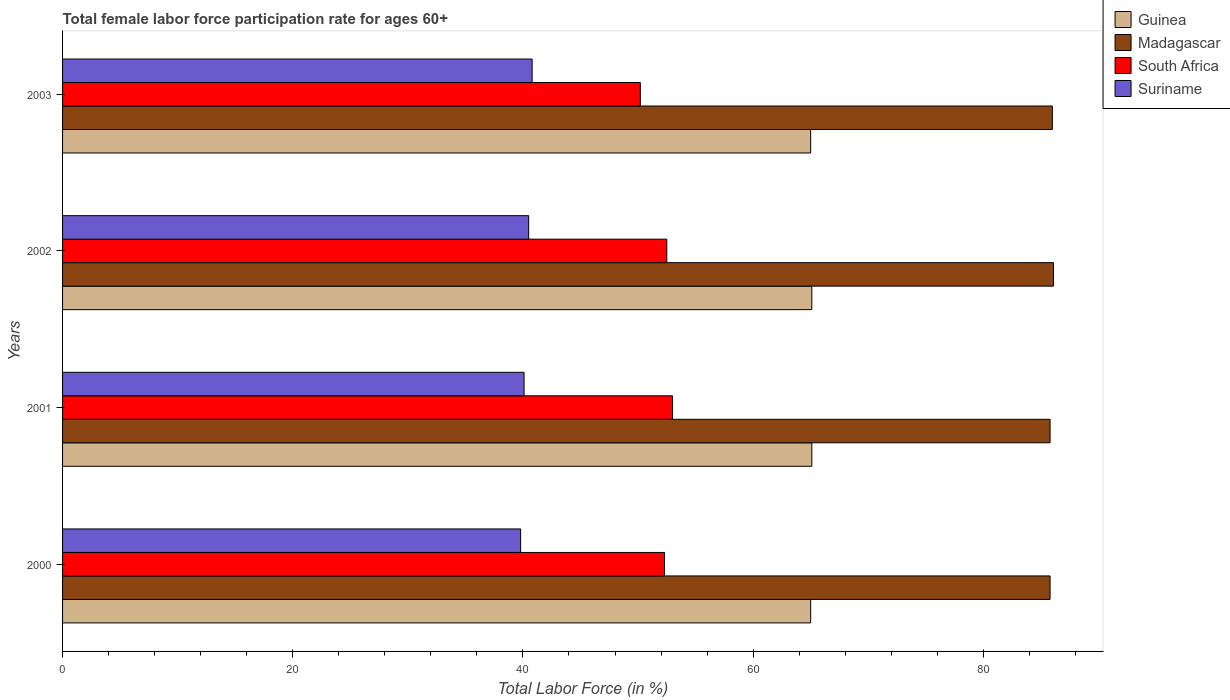How many different coloured bars are there?
Ensure brevity in your answer.  4. How many groups of bars are there?
Make the answer very short. 4. How many bars are there on the 4th tick from the bottom?
Ensure brevity in your answer.  4. In how many cases, is the number of bars for a given year not equal to the number of legend labels?
Your response must be concise. 0. What is the female labor force participation rate in South Africa in 2003?
Offer a terse response. 50.2. Across all years, what is the minimum female labor force participation rate in Suriname?
Make the answer very short. 39.8. In which year was the female labor force participation rate in Suriname maximum?
Make the answer very short. 2003. In which year was the female labor force participation rate in South Africa minimum?
Your answer should be compact. 2003. What is the total female labor force participation rate in South Africa in the graph?
Make the answer very short. 208. What is the difference between the female labor force participation rate in Suriname in 2000 and that in 2003?
Ensure brevity in your answer.  -1. In the year 2003, what is the difference between the female labor force participation rate in South Africa and female labor force participation rate in Suriname?
Your answer should be compact. 9.4. In how many years, is the female labor force participation rate in Madagascar greater than 40 %?
Your answer should be compact. 4. What is the ratio of the female labor force participation rate in Suriname in 2001 to that in 2003?
Ensure brevity in your answer.  0.98. Is the female labor force participation rate in Suriname in 2001 less than that in 2003?
Your answer should be very brief. Yes. What is the difference between the highest and the second highest female labor force participation rate in Madagascar?
Your answer should be very brief. 0.1. What is the difference between the highest and the lowest female labor force participation rate in Guinea?
Give a very brief answer. 0.1. In how many years, is the female labor force participation rate in Guinea greater than the average female labor force participation rate in Guinea taken over all years?
Your response must be concise. 2. Is the sum of the female labor force participation rate in Suriname in 2001 and 2003 greater than the maximum female labor force participation rate in Guinea across all years?
Give a very brief answer. Yes. What does the 4th bar from the top in 2002 represents?
Keep it short and to the point. Guinea. What does the 3rd bar from the bottom in 2002 represents?
Provide a succinct answer. South Africa. Is it the case that in every year, the sum of the female labor force participation rate in Guinea and female labor force participation rate in South Africa is greater than the female labor force participation rate in Suriname?
Keep it short and to the point. Yes. Are all the bars in the graph horizontal?
Your answer should be very brief. Yes. How many years are there in the graph?
Keep it short and to the point. 4. What is the difference between two consecutive major ticks on the X-axis?
Ensure brevity in your answer.  20. Does the graph contain grids?
Keep it short and to the point. No. What is the title of the graph?
Keep it short and to the point. Total female labor force participation rate for ages 60+. Does "Honduras" appear as one of the legend labels in the graph?
Offer a terse response. No. What is the label or title of the X-axis?
Ensure brevity in your answer.  Total Labor Force (in %). What is the Total Labor Force (in %) of Guinea in 2000?
Provide a succinct answer. 65. What is the Total Labor Force (in %) of Madagascar in 2000?
Ensure brevity in your answer.  85.8. What is the Total Labor Force (in %) of South Africa in 2000?
Keep it short and to the point. 52.3. What is the Total Labor Force (in %) in Suriname in 2000?
Your response must be concise. 39.8. What is the Total Labor Force (in %) of Guinea in 2001?
Offer a terse response. 65.1. What is the Total Labor Force (in %) in Madagascar in 2001?
Your response must be concise. 85.8. What is the Total Labor Force (in %) of South Africa in 2001?
Ensure brevity in your answer.  53. What is the Total Labor Force (in %) of Suriname in 2001?
Your answer should be compact. 40.1. What is the Total Labor Force (in %) in Guinea in 2002?
Make the answer very short. 65.1. What is the Total Labor Force (in %) of Madagascar in 2002?
Provide a succinct answer. 86.1. What is the Total Labor Force (in %) in South Africa in 2002?
Your answer should be compact. 52.5. What is the Total Labor Force (in %) of Suriname in 2002?
Offer a very short reply. 40.5. What is the Total Labor Force (in %) in Guinea in 2003?
Ensure brevity in your answer.  65. What is the Total Labor Force (in %) in Madagascar in 2003?
Ensure brevity in your answer.  86. What is the Total Labor Force (in %) of South Africa in 2003?
Your response must be concise. 50.2. What is the Total Labor Force (in %) of Suriname in 2003?
Your answer should be compact. 40.8. Across all years, what is the maximum Total Labor Force (in %) in Guinea?
Make the answer very short. 65.1. Across all years, what is the maximum Total Labor Force (in %) in Madagascar?
Your answer should be very brief. 86.1. Across all years, what is the maximum Total Labor Force (in %) of Suriname?
Offer a terse response. 40.8. Across all years, what is the minimum Total Labor Force (in %) of Guinea?
Ensure brevity in your answer.  65. Across all years, what is the minimum Total Labor Force (in %) in Madagascar?
Your answer should be compact. 85.8. Across all years, what is the minimum Total Labor Force (in %) in South Africa?
Provide a succinct answer. 50.2. Across all years, what is the minimum Total Labor Force (in %) in Suriname?
Offer a terse response. 39.8. What is the total Total Labor Force (in %) in Guinea in the graph?
Give a very brief answer. 260.2. What is the total Total Labor Force (in %) of Madagascar in the graph?
Make the answer very short. 343.7. What is the total Total Labor Force (in %) in South Africa in the graph?
Make the answer very short. 208. What is the total Total Labor Force (in %) in Suriname in the graph?
Offer a terse response. 161.2. What is the difference between the Total Labor Force (in %) in Guinea in 2000 and that in 2001?
Ensure brevity in your answer.  -0.1. What is the difference between the Total Labor Force (in %) of South Africa in 2000 and that in 2001?
Offer a terse response. -0.7. What is the difference between the Total Labor Force (in %) of Guinea in 2000 and that in 2002?
Your response must be concise. -0.1. What is the difference between the Total Labor Force (in %) of Madagascar in 2000 and that in 2003?
Your answer should be very brief. -0.2. What is the difference between the Total Labor Force (in %) in South Africa in 2000 and that in 2003?
Provide a short and direct response. 2.1. What is the difference between the Total Labor Force (in %) of Suriname in 2000 and that in 2003?
Provide a succinct answer. -1. What is the difference between the Total Labor Force (in %) in Guinea in 2001 and that in 2002?
Your response must be concise. 0. What is the difference between the Total Labor Force (in %) of Madagascar in 2001 and that in 2002?
Give a very brief answer. -0.3. What is the difference between the Total Labor Force (in %) of South Africa in 2001 and that in 2002?
Keep it short and to the point. 0.5. What is the difference between the Total Labor Force (in %) of Guinea in 2001 and that in 2003?
Give a very brief answer. 0.1. What is the difference between the Total Labor Force (in %) in South Africa in 2001 and that in 2003?
Keep it short and to the point. 2.8. What is the difference between the Total Labor Force (in %) in Suriname in 2001 and that in 2003?
Your response must be concise. -0.7. What is the difference between the Total Labor Force (in %) of Guinea in 2002 and that in 2003?
Give a very brief answer. 0.1. What is the difference between the Total Labor Force (in %) in Madagascar in 2002 and that in 2003?
Make the answer very short. 0.1. What is the difference between the Total Labor Force (in %) of Suriname in 2002 and that in 2003?
Provide a succinct answer. -0.3. What is the difference between the Total Labor Force (in %) in Guinea in 2000 and the Total Labor Force (in %) in Madagascar in 2001?
Your answer should be very brief. -20.8. What is the difference between the Total Labor Force (in %) of Guinea in 2000 and the Total Labor Force (in %) of Suriname in 2001?
Provide a succinct answer. 24.9. What is the difference between the Total Labor Force (in %) of Madagascar in 2000 and the Total Labor Force (in %) of South Africa in 2001?
Make the answer very short. 32.8. What is the difference between the Total Labor Force (in %) in Madagascar in 2000 and the Total Labor Force (in %) in Suriname in 2001?
Give a very brief answer. 45.7. What is the difference between the Total Labor Force (in %) of South Africa in 2000 and the Total Labor Force (in %) of Suriname in 2001?
Offer a terse response. 12.2. What is the difference between the Total Labor Force (in %) in Guinea in 2000 and the Total Labor Force (in %) in Madagascar in 2002?
Offer a terse response. -21.1. What is the difference between the Total Labor Force (in %) in Madagascar in 2000 and the Total Labor Force (in %) in South Africa in 2002?
Offer a very short reply. 33.3. What is the difference between the Total Labor Force (in %) of Madagascar in 2000 and the Total Labor Force (in %) of Suriname in 2002?
Provide a short and direct response. 45.3. What is the difference between the Total Labor Force (in %) of Guinea in 2000 and the Total Labor Force (in %) of South Africa in 2003?
Offer a very short reply. 14.8. What is the difference between the Total Labor Force (in %) of Guinea in 2000 and the Total Labor Force (in %) of Suriname in 2003?
Your answer should be compact. 24.2. What is the difference between the Total Labor Force (in %) of Madagascar in 2000 and the Total Labor Force (in %) of South Africa in 2003?
Provide a short and direct response. 35.6. What is the difference between the Total Labor Force (in %) in Madagascar in 2000 and the Total Labor Force (in %) in Suriname in 2003?
Your answer should be very brief. 45. What is the difference between the Total Labor Force (in %) of South Africa in 2000 and the Total Labor Force (in %) of Suriname in 2003?
Provide a short and direct response. 11.5. What is the difference between the Total Labor Force (in %) in Guinea in 2001 and the Total Labor Force (in %) in Madagascar in 2002?
Your response must be concise. -21. What is the difference between the Total Labor Force (in %) in Guinea in 2001 and the Total Labor Force (in %) in South Africa in 2002?
Offer a terse response. 12.6. What is the difference between the Total Labor Force (in %) of Guinea in 2001 and the Total Labor Force (in %) of Suriname in 2002?
Give a very brief answer. 24.6. What is the difference between the Total Labor Force (in %) in Madagascar in 2001 and the Total Labor Force (in %) in South Africa in 2002?
Ensure brevity in your answer.  33.3. What is the difference between the Total Labor Force (in %) in Madagascar in 2001 and the Total Labor Force (in %) in Suriname in 2002?
Provide a short and direct response. 45.3. What is the difference between the Total Labor Force (in %) in South Africa in 2001 and the Total Labor Force (in %) in Suriname in 2002?
Give a very brief answer. 12.5. What is the difference between the Total Labor Force (in %) in Guinea in 2001 and the Total Labor Force (in %) in Madagascar in 2003?
Offer a very short reply. -20.9. What is the difference between the Total Labor Force (in %) of Guinea in 2001 and the Total Labor Force (in %) of South Africa in 2003?
Your answer should be very brief. 14.9. What is the difference between the Total Labor Force (in %) in Guinea in 2001 and the Total Labor Force (in %) in Suriname in 2003?
Keep it short and to the point. 24.3. What is the difference between the Total Labor Force (in %) of Madagascar in 2001 and the Total Labor Force (in %) of South Africa in 2003?
Make the answer very short. 35.6. What is the difference between the Total Labor Force (in %) in Madagascar in 2001 and the Total Labor Force (in %) in Suriname in 2003?
Keep it short and to the point. 45. What is the difference between the Total Labor Force (in %) in Guinea in 2002 and the Total Labor Force (in %) in Madagascar in 2003?
Provide a succinct answer. -20.9. What is the difference between the Total Labor Force (in %) of Guinea in 2002 and the Total Labor Force (in %) of South Africa in 2003?
Ensure brevity in your answer.  14.9. What is the difference between the Total Labor Force (in %) in Guinea in 2002 and the Total Labor Force (in %) in Suriname in 2003?
Provide a succinct answer. 24.3. What is the difference between the Total Labor Force (in %) in Madagascar in 2002 and the Total Labor Force (in %) in South Africa in 2003?
Ensure brevity in your answer.  35.9. What is the difference between the Total Labor Force (in %) in Madagascar in 2002 and the Total Labor Force (in %) in Suriname in 2003?
Ensure brevity in your answer.  45.3. What is the difference between the Total Labor Force (in %) in South Africa in 2002 and the Total Labor Force (in %) in Suriname in 2003?
Provide a short and direct response. 11.7. What is the average Total Labor Force (in %) in Guinea per year?
Provide a short and direct response. 65.05. What is the average Total Labor Force (in %) in Madagascar per year?
Provide a short and direct response. 85.92. What is the average Total Labor Force (in %) of South Africa per year?
Provide a succinct answer. 52. What is the average Total Labor Force (in %) of Suriname per year?
Provide a short and direct response. 40.3. In the year 2000, what is the difference between the Total Labor Force (in %) of Guinea and Total Labor Force (in %) of Madagascar?
Make the answer very short. -20.8. In the year 2000, what is the difference between the Total Labor Force (in %) of Guinea and Total Labor Force (in %) of South Africa?
Your answer should be compact. 12.7. In the year 2000, what is the difference between the Total Labor Force (in %) in Guinea and Total Labor Force (in %) in Suriname?
Offer a terse response. 25.2. In the year 2000, what is the difference between the Total Labor Force (in %) of Madagascar and Total Labor Force (in %) of South Africa?
Ensure brevity in your answer.  33.5. In the year 2000, what is the difference between the Total Labor Force (in %) in Madagascar and Total Labor Force (in %) in Suriname?
Provide a succinct answer. 46. In the year 2001, what is the difference between the Total Labor Force (in %) in Guinea and Total Labor Force (in %) in Madagascar?
Offer a terse response. -20.7. In the year 2001, what is the difference between the Total Labor Force (in %) in Guinea and Total Labor Force (in %) in South Africa?
Provide a succinct answer. 12.1. In the year 2001, what is the difference between the Total Labor Force (in %) of Guinea and Total Labor Force (in %) of Suriname?
Provide a succinct answer. 25. In the year 2001, what is the difference between the Total Labor Force (in %) in Madagascar and Total Labor Force (in %) in South Africa?
Provide a short and direct response. 32.8. In the year 2001, what is the difference between the Total Labor Force (in %) in Madagascar and Total Labor Force (in %) in Suriname?
Your answer should be very brief. 45.7. In the year 2002, what is the difference between the Total Labor Force (in %) of Guinea and Total Labor Force (in %) of Madagascar?
Make the answer very short. -21. In the year 2002, what is the difference between the Total Labor Force (in %) in Guinea and Total Labor Force (in %) in Suriname?
Offer a very short reply. 24.6. In the year 2002, what is the difference between the Total Labor Force (in %) in Madagascar and Total Labor Force (in %) in South Africa?
Make the answer very short. 33.6. In the year 2002, what is the difference between the Total Labor Force (in %) in Madagascar and Total Labor Force (in %) in Suriname?
Your response must be concise. 45.6. In the year 2003, what is the difference between the Total Labor Force (in %) in Guinea and Total Labor Force (in %) in Madagascar?
Make the answer very short. -21. In the year 2003, what is the difference between the Total Labor Force (in %) of Guinea and Total Labor Force (in %) of Suriname?
Make the answer very short. 24.2. In the year 2003, what is the difference between the Total Labor Force (in %) in Madagascar and Total Labor Force (in %) in South Africa?
Provide a short and direct response. 35.8. In the year 2003, what is the difference between the Total Labor Force (in %) of Madagascar and Total Labor Force (in %) of Suriname?
Provide a short and direct response. 45.2. What is the ratio of the Total Labor Force (in %) of Guinea in 2000 to that in 2002?
Offer a very short reply. 1. What is the ratio of the Total Labor Force (in %) in Madagascar in 2000 to that in 2002?
Ensure brevity in your answer.  1. What is the ratio of the Total Labor Force (in %) of Suriname in 2000 to that in 2002?
Your answer should be compact. 0.98. What is the ratio of the Total Labor Force (in %) of Madagascar in 2000 to that in 2003?
Offer a terse response. 1. What is the ratio of the Total Labor Force (in %) in South Africa in 2000 to that in 2003?
Your answer should be compact. 1.04. What is the ratio of the Total Labor Force (in %) of Suriname in 2000 to that in 2003?
Offer a terse response. 0.98. What is the ratio of the Total Labor Force (in %) in Guinea in 2001 to that in 2002?
Your answer should be very brief. 1. What is the ratio of the Total Labor Force (in %) in Madagascar in 2001 to that in 2002?
Your response must be concise. 1. What is the ratio of the Total Labor Force (in %) in South Africa in 2001 to that in 2002?
Give a very brief answer. 1.01. What is the ratio of the Total Labor Force (in %) of Suriname in 2001 to that in 2002?
Make the answer very short. 0.99. What is the ratio of the Total Labor Force (in %) of Guinea in 2001 to that in 2003?
Provide a short and direct response. 1. What is the ratio of the Total Labor Force (in %) in South Africa in 2001 to that in 2003?
Make the answer very short. 1.06. What is the ratio of the Total Labor Force (in %) in Suriname in 2001 to that in 2003?
Offer a very short reply. 0.98. What is the ratio of the Total Labor Force (in %) of Guinea in 2002 to that in 2003?
Offer a terse response. 1. What is the ratio of the Total Labor Force (in %) in South Africa in 2002 to that in 2003?
Offer a terse response. 1.05. What is the ratio of the Total Labor Force (in %) in Suriname in 2002 to that in 2003?
Keep it short and to the point. 0.99. What is the difference between the highest and the second highest Total Labor Force (in %) of Guinea?
Offer a very short reply. 0. What is the difference between the highest and the second highest Total Labor Force (in %) of Madagascar?
Offer a terse response. 0.1. What is the difference between the highest and the second highest Total Labor Force (in %) in South Africa?
Make the answer very short. 0.5. What is the difference between the highest and the second highest Total Labor Force (in %) of Suriname?
Give a very brief answer. 0.3. What is the difference between the highest and the lowest Total Labor Force (in %) of South Africa?
Ensure brevity in your answer.  2.8. 